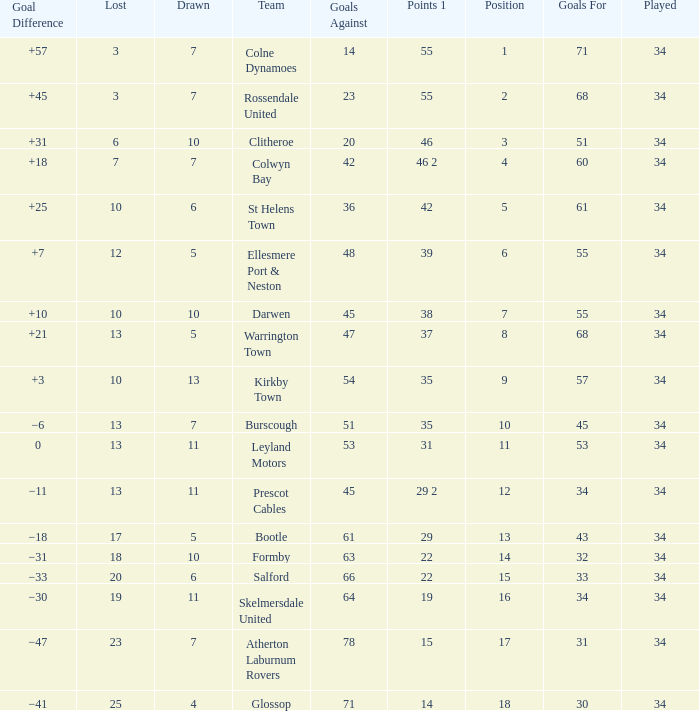Which Goals For has a Lost of 12, and a Played larger than 34? None. 